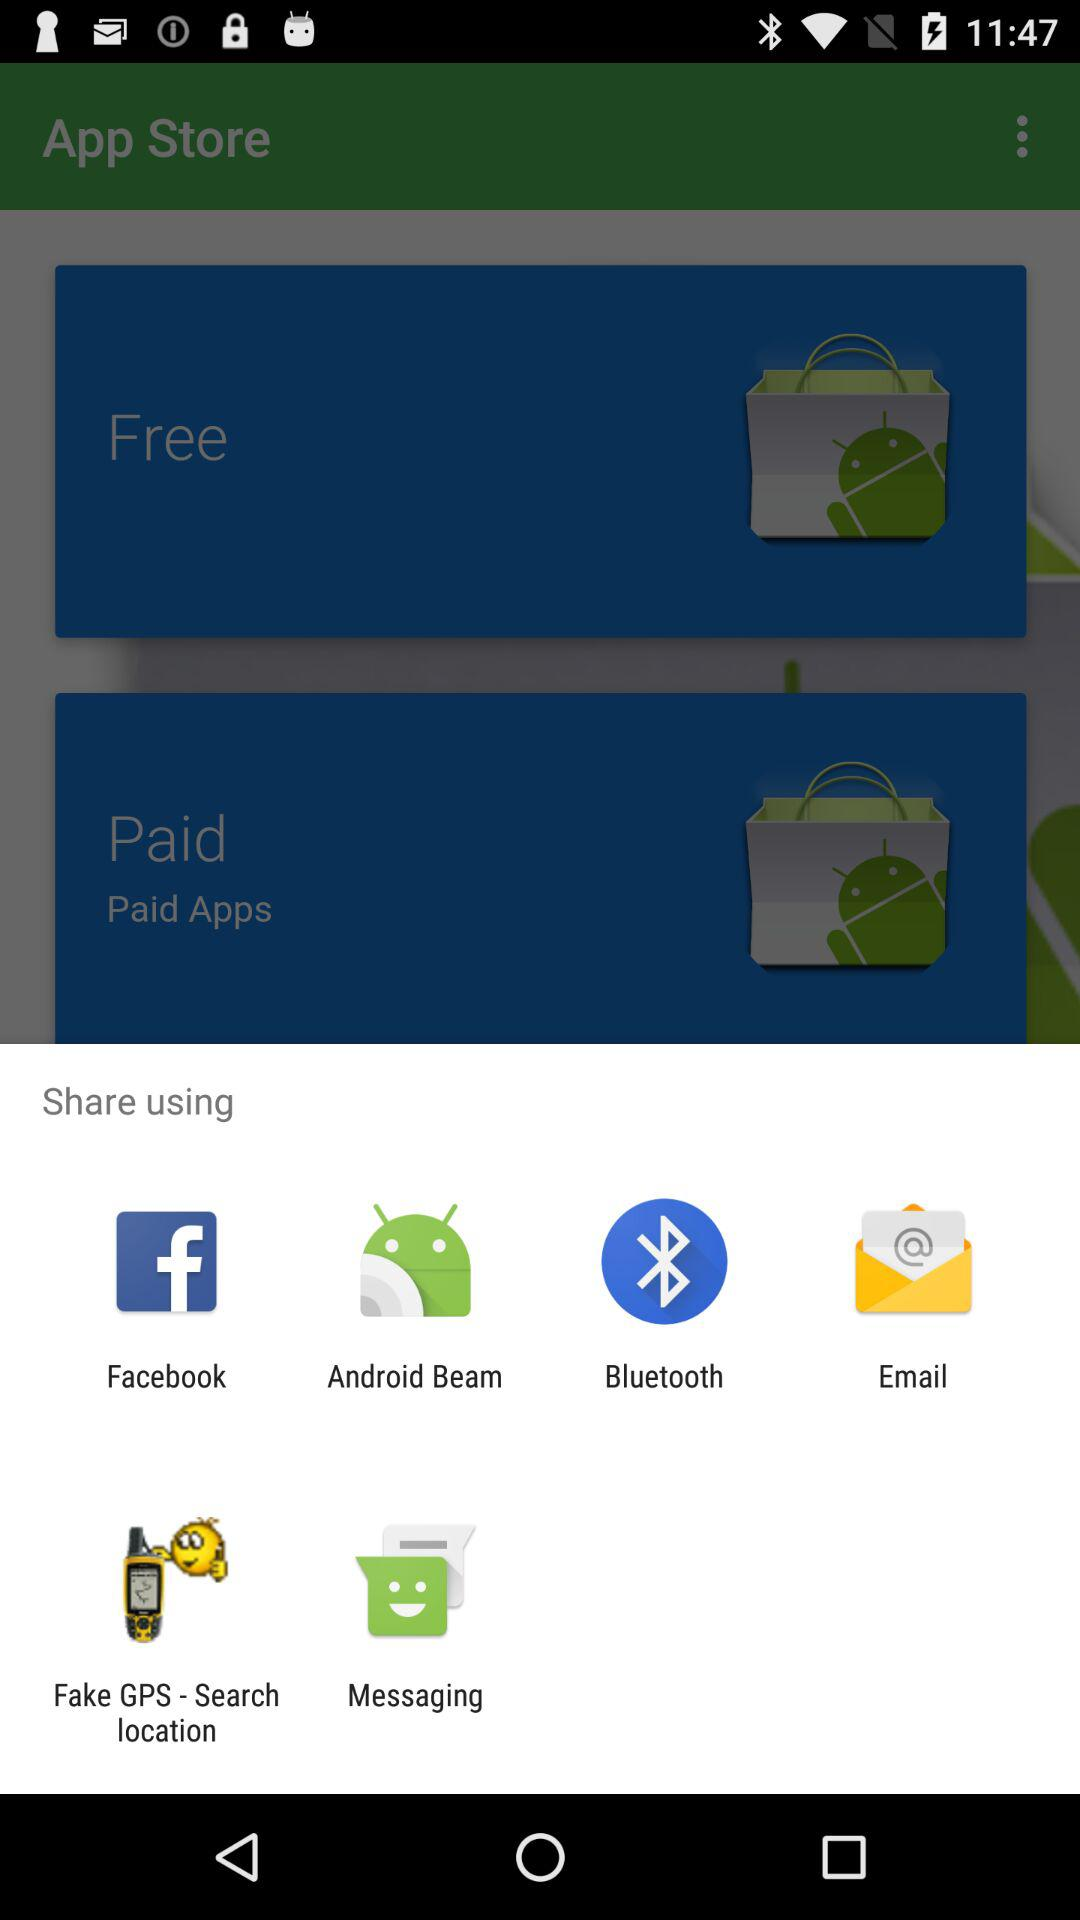What applications can be use to share? You can share it with "Facebook", "Android Beam", "Bluetooth", "Email", "Fake GPS - Search location" and "Messaging". 